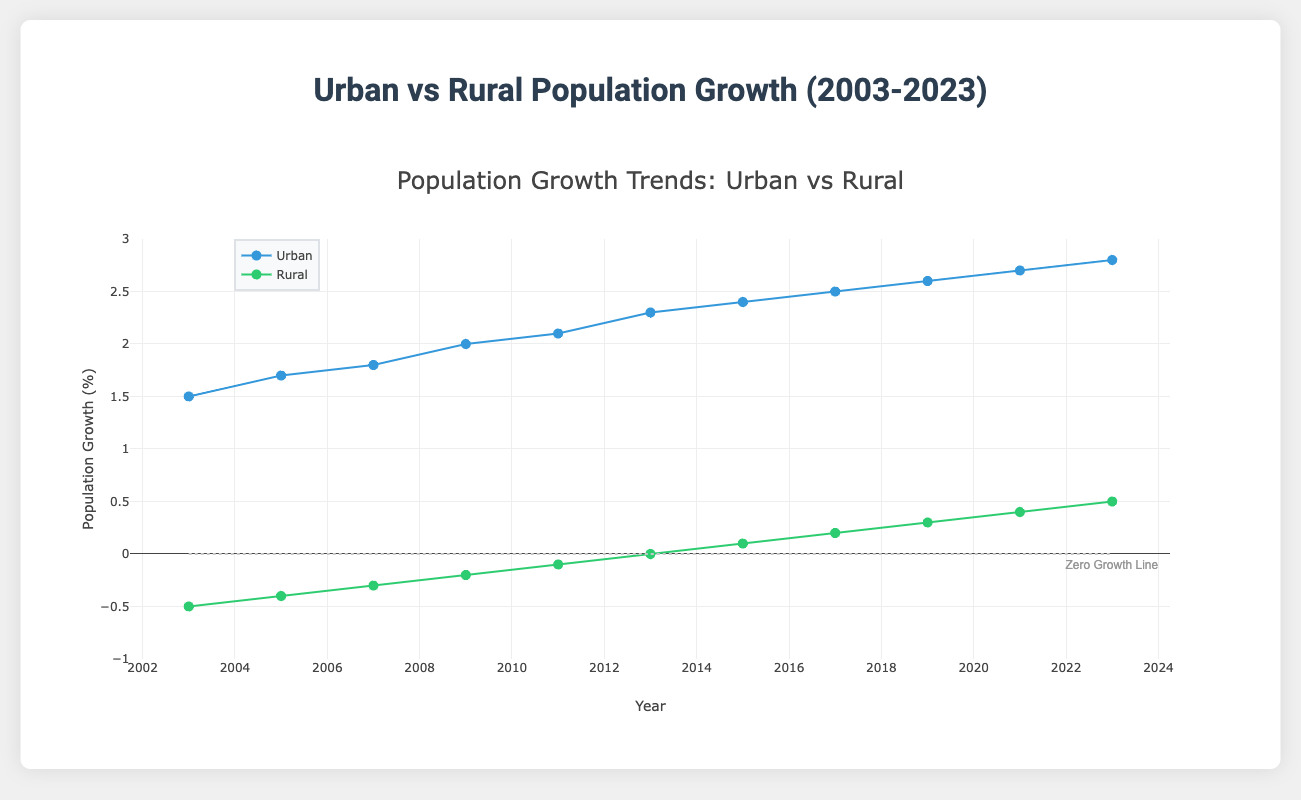What is the title of the plot? The title of the plot is displayed at the top center of the figure. It helps the viewer understand what the plot represents immediately. In this case, observe the large text at the top.
Answer: Urban vs Rural Population Growth (2003-2023) How many data points are there for urban and rural population growth? To find this, count the number of markers (points) on the plot for either urban or rural population growth. Each year corresponds to one data point. Since points are plotted for the years 2003 to 2023, count all these points.
Answer: 11 Which population group had negative growth in 2003? Look at the y-axis scale and find the value corresponding to the year 2003 on the x-axis for both lines. Identify which group’s data point falls below the zero line.
Answer: Rural What is the difference in urban population growth between 2003 and 2023? Locate the data points for 2003 and 2023 for urban population growth. The value for 2003 is 1.5%, and the value for 2023 is 2.8%. Subtract 1.5 from 2.8 to find the difference.
Answer: 1.3% By what year did rural population growth turn positive? Find the rural population growth curve and identify the year when the data point first moved from below the zero line to above the zero line.
Answer: 2013 What is the average urban population growth over the 20 years? Add all the urban population growth values and divide by the number of data points. The values are 1.5, 1.7, 1.8, 2.0, 2.1, 2.3, 2.4, 2.5, 2.6, 2.7, and 2.8. Calculate the sum and then divide by 11.
Answer: 2.173% Which year had the highest rural population growth? Examine the data points for the rural population growth trend line and identify the year with the highest value. The highest value appears at the end of the x-axis.
Answer: 2023 Which group experienced a greater overall increase in population growth from 2003 to 2023? Calculate the difference in population growth from 2003 to 2023 for both urban and rural groups. Compare the differences for both groups. Urban increased by 1.3% (2.8 - 1.5) and rural increased by 1.0% (0.5 - (-0.5)). Urban had a greater increase.
Answer: Urban At which year did urban population growth exceed 2% for the first time? Trace the urban population growth data points and identify when the value first crosses above 2%. Look for the point where it changes from below 2% to above 2%.
Answer: 2009 How does the trend of urban population growth compare to that of rural population growth? Look at both trend lines. Urban population growth shows a consistent upward trend from 1.5% to 2.8%, while rural population growth starts negative, reaches zero by 2013, and then continues a slow upward trend to 0.5% by 2023. Urban shows stronger and steadier growth.
Answer: Urban shows stronger and steadier growth 